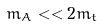<formula> <loc_0><loc_0><loc_500><loc_500>m _ { A } < < 2 m _ { t }</formula> 